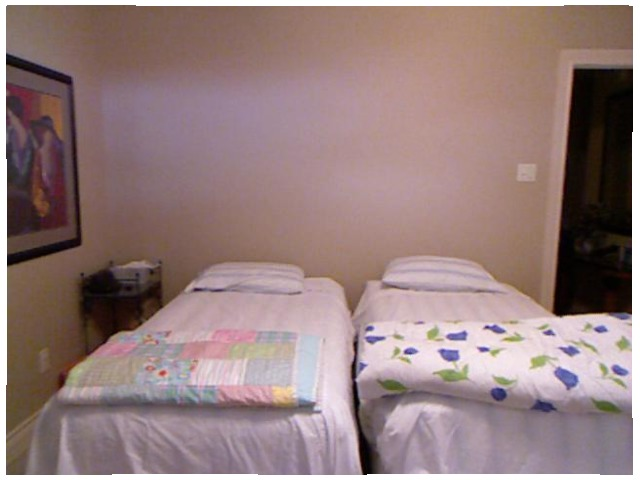<image>
Is the painting above the outlet? Yes. The painting is positioned above the outlet in the vertical space, higher up in the scene. Where is the bed in relation to the blanket? Is it on the blanket? No. The bed is not positioned on the blanket. They may be near each other, but the bed is not supported by or resting on top of the blanket. Is there a pillow on the bed? No. The pillow is not positioned on the bed. They may be near each other, but the pillow is not supported by or resting on top of the bed. Where is the wall in relation to the bed? Is it behind the bed? Yes. From this viewpoint, the wall is positioned behind the bed, with the bed partially or fully occluding the wall. 